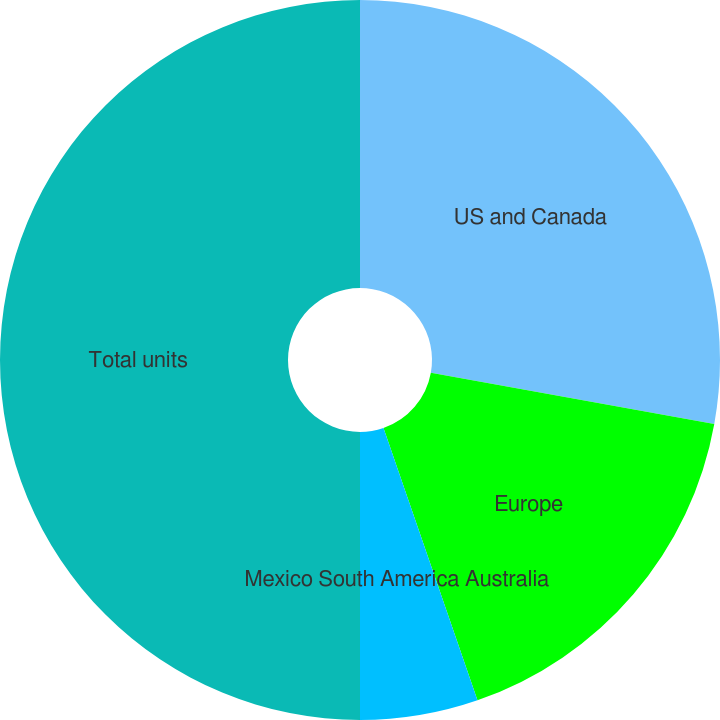Convert chart to OTSL. <chart><loc_0><loc_0><loc_500><loc_500><pie_chart><fcel>US and Canada<fcel>Europe<fcel>Mexico South America Australia<fcel>Total units<nl><fcel>27.84%<fcel>16.87%<fcel>5.29%<fcel>50.0%<nl></chart> 